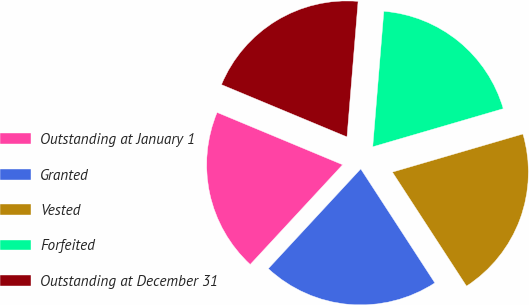Convert chart. <chart><loc_0><loc_0><loc_500><loc_500><pie_chart><fcel>Outstanding at January 1<fcel>Granted<fcel>Vested<fcel>Forfeited<fcel>Outstanding at December 31<nl><fcel>19.39%<fcel>21.07%<fcel>20.35%<fcel>19.18%<fcel>20.02%<nl></chart> 